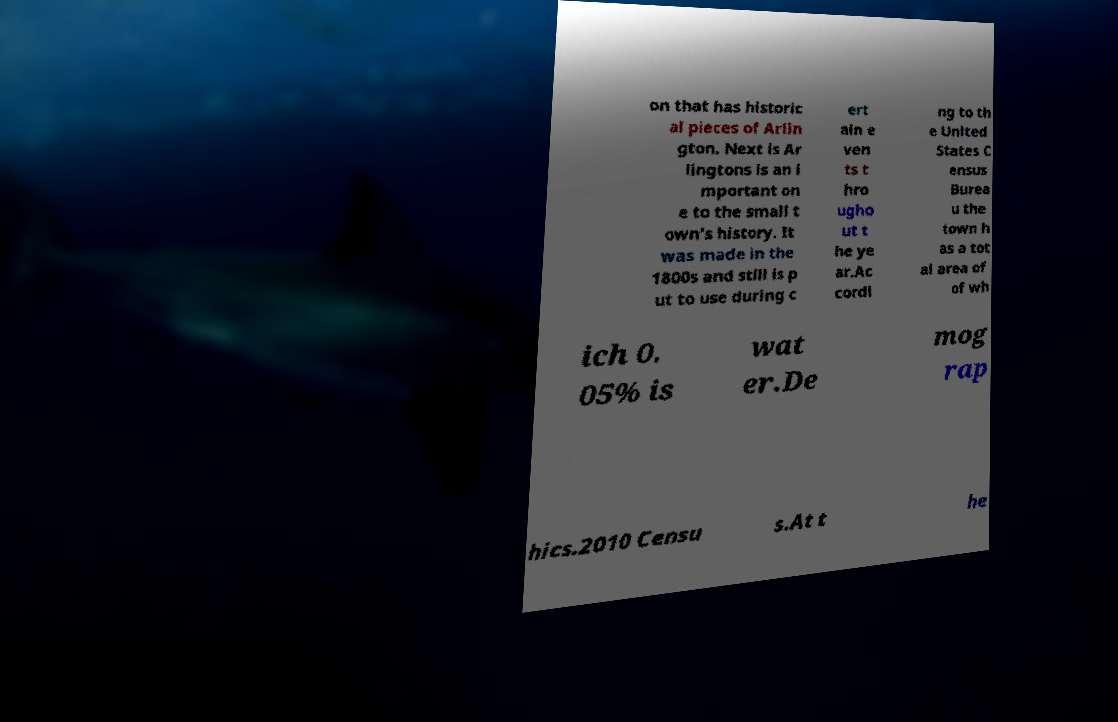Please read and relay the text visible in this image. What does it say? on that has historic al pieces of Arlin gton. Next is Ar lingtons is an i mportant on e to the small t own’s history. It was made in the 1800s and still is p ut to use during c ert ain e ven ts t hro ugho ut t he ye ar.Ac cordi ng to th e United States C ensus Burea u the town h as a tot al area of of wh ich 0. 05% is wat er.De mog rap hics.2010 Censu s.At t he 